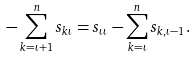<formula> <loc_0><loc_0><loc_500><loc_500>- \sum _ { k = \iota + 1 } ^ { n } s _ { k \iota } = s _ { \iota \iota } - \sum _ { k = \iota } ^ { n } s _ { k , \iota - 1 } .</formula> 